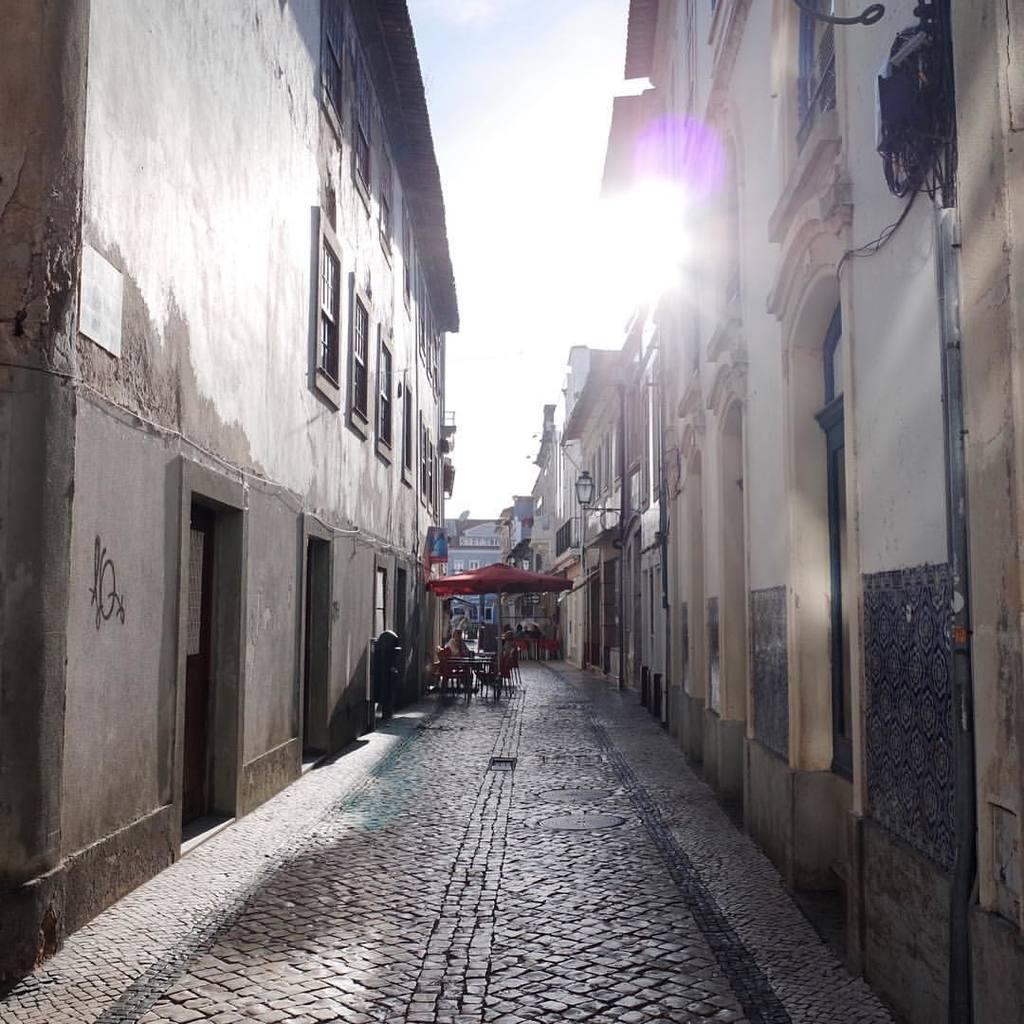Could you give a brief overview of what you see in this image? On the right there are buildings. On the left we can see windows, doors, building and a person. In the center of the background there are buildings, carts, lamp and other objects. In the foreground it is road. At the top it is sky. The sky is sunny. 